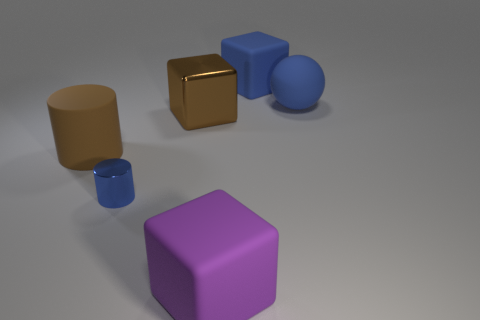Speculate on the size of the objects based on the image. While the direct size of the objects is not known without a reference scale, we can infer relative sizes. The blue cylinder and the purple cube are comparable in size and appear to be moderately sized, potentially hand-held. The tan and metal cylinders are smaller, possibly half the size of the blue cylinder or less. The sphere is approximately the same size as the blue cylinder, whereas the small golden cube is notably smaller in comparison, and the larger golden cube is the largest object in the scene. 